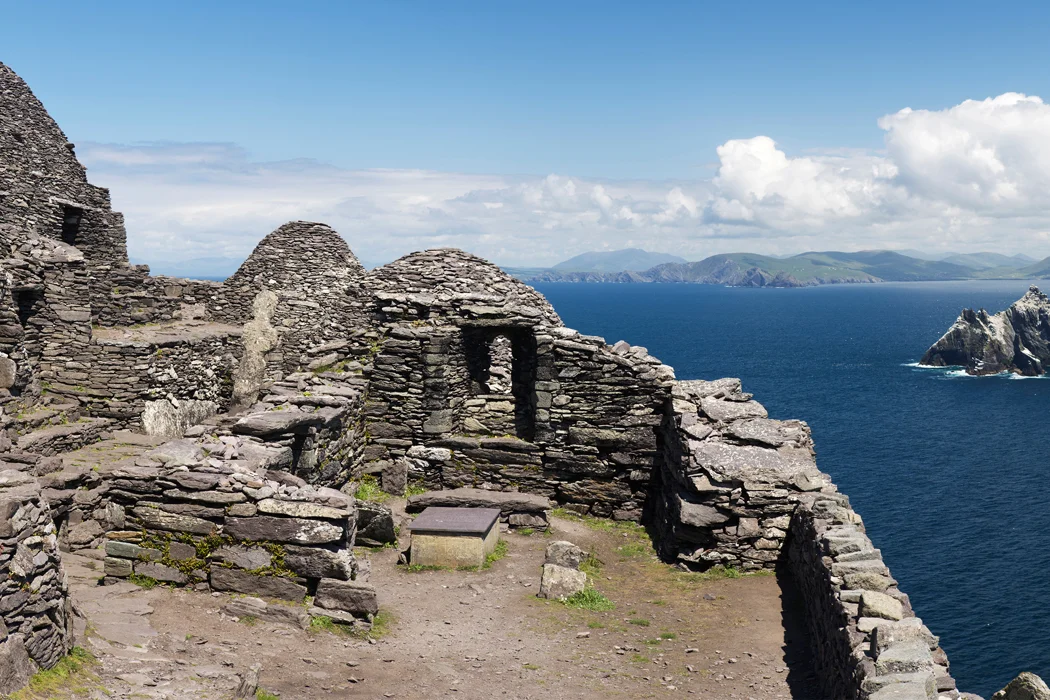Write a detailed description of the given image. This image captures the breathtaking view of Skellig Michael, one of the Skellig Islands located off the coast of Ireland. The ruins of an ancient stone structure, possibly a monastery, stand as a testament to the passage of time, weathered by the elements but still standing strong. The perspective of the image is from a high vantage point, offering a panoramic view of the deep blue ocean that surrounds the island. The sky above mirrors the ocean's hue, albeit a shade lighter, dotted with a few clouds. In the distance, the silhouette of the other Skellig Islands can be seen, adding depth to the scene. The image is a beautiful blend of history and nature, showcasing the rugged beauty of Ireland's coastal landmarks. 